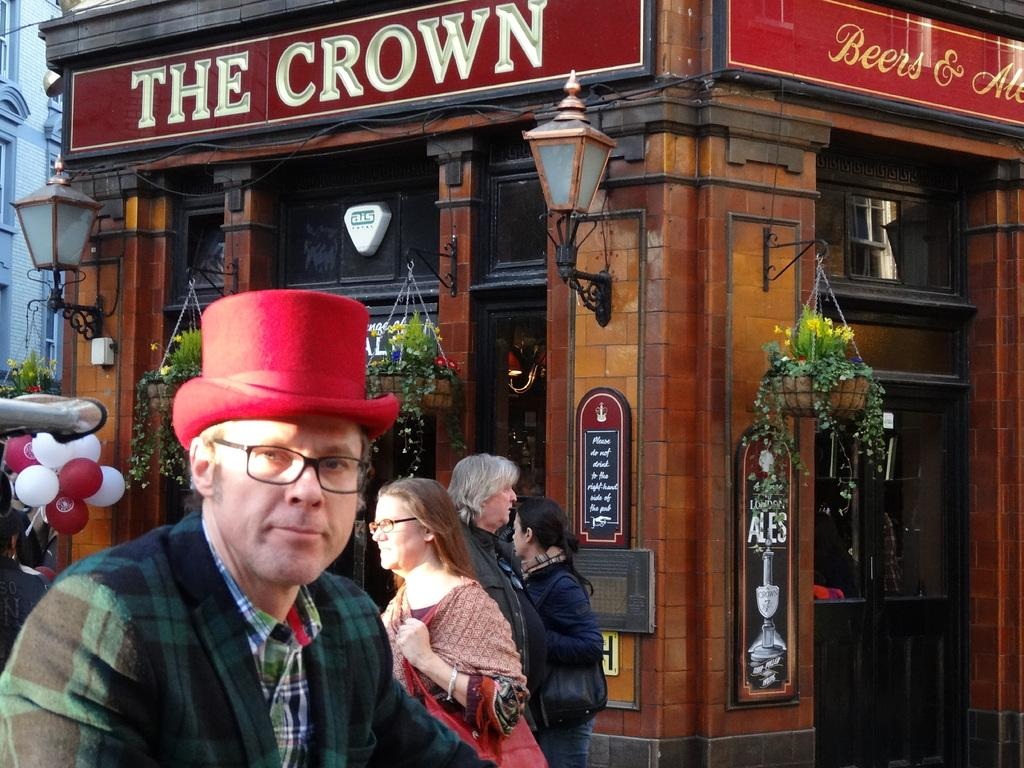What can be seen in the foreground of the picture? There are people in the foreground of the picture. What objects are located in the middle of the picture? There are lamps, flower pots, flowers, a board, and a building in the middle of the picture. What is on the left side of the picture? There are balloons and a building on the left side of the picture. Can you tell me how many veins are visible in the picture? There are no veins visible in the picture. Are there any flies present in the image? There is no mention of flies in the provided facts, so it cannot be determined if any are present in the image. 